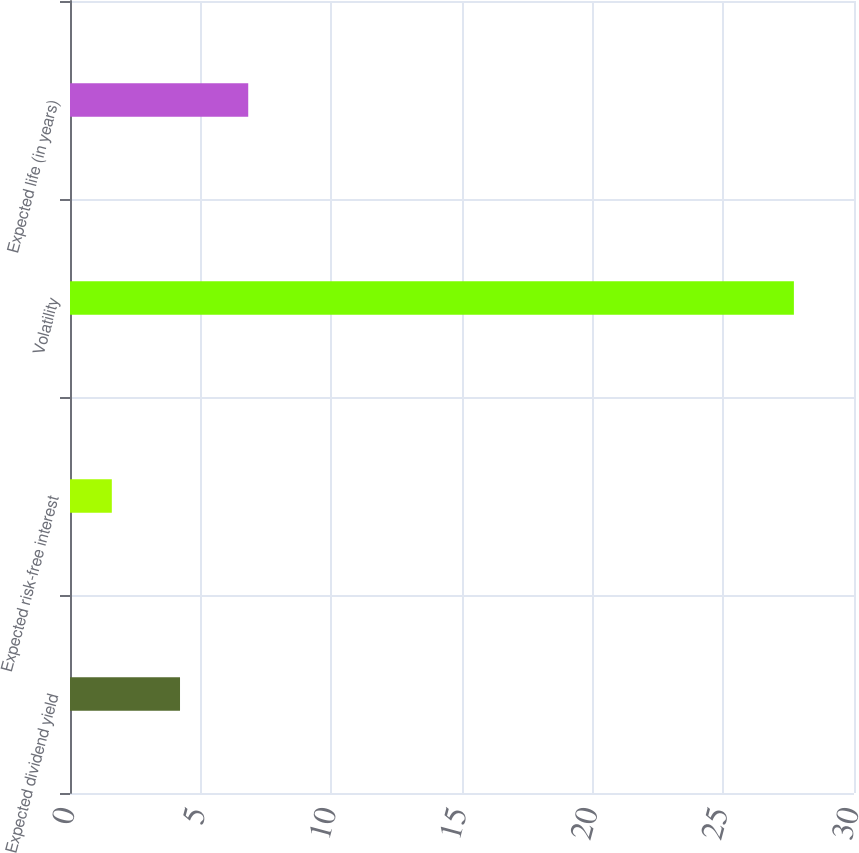<chart> <loc_0><loc_0><loc_500><loc_500><bar_chart><fcel>Expected dividend yield<fcel>Expected risk-free interest<fcel>Volatility<fcel>Expected life (in years)<nl><fcel>4.21<fcel>1.6<fcel>27.7<fcel>6.82<nl></chart> 